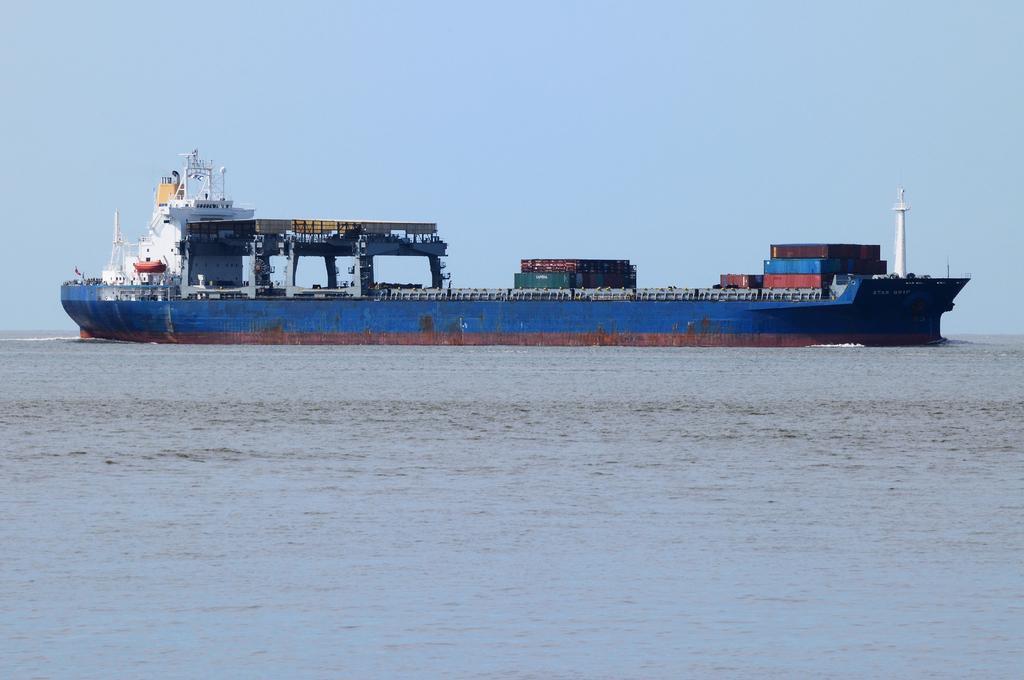Could you give a brief overview of what you see in this image? In this image we can see a ship which is in blue color moving on water and we can see water, clear sky. 